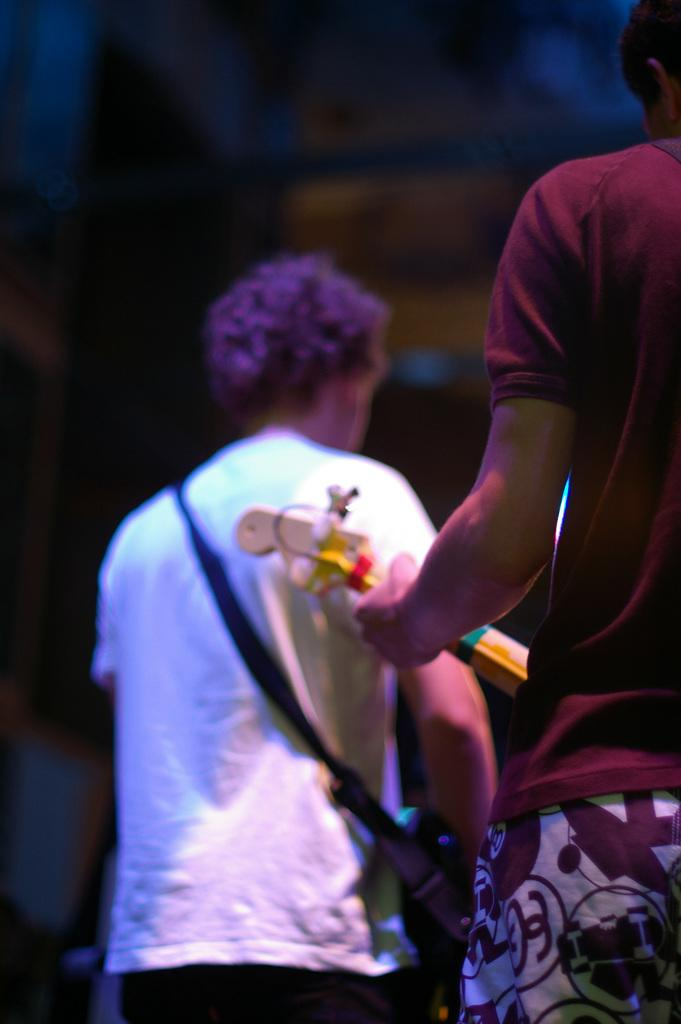How many people are in the image? There are two people in the image. What is the man holding in the image? The man is holding a guitar. What can be observed about the background of the image? The background of the image is dark. How many frogs are sitting on the guitar in the image? There are no frogs present in the image, and the guitar is not being used as a seat for any frogs. 